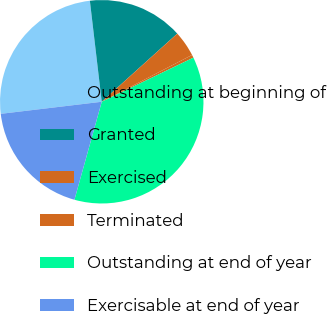<chart> <loc_0><loc_0><loc_500><loc_500><pie_chart><fcel>Outstanding at beginning of<fcel>Granted<fcel>Exercised<fcel>Terminated<fcel>Outstanding at end of year<fcel>Exercisable at end of year<nl><fcel>25.03%<fcel>15.18%<fcel>4.07%<fcel>0.47%<fcel>36.46%<fcel>18.78%<nl></chart> 